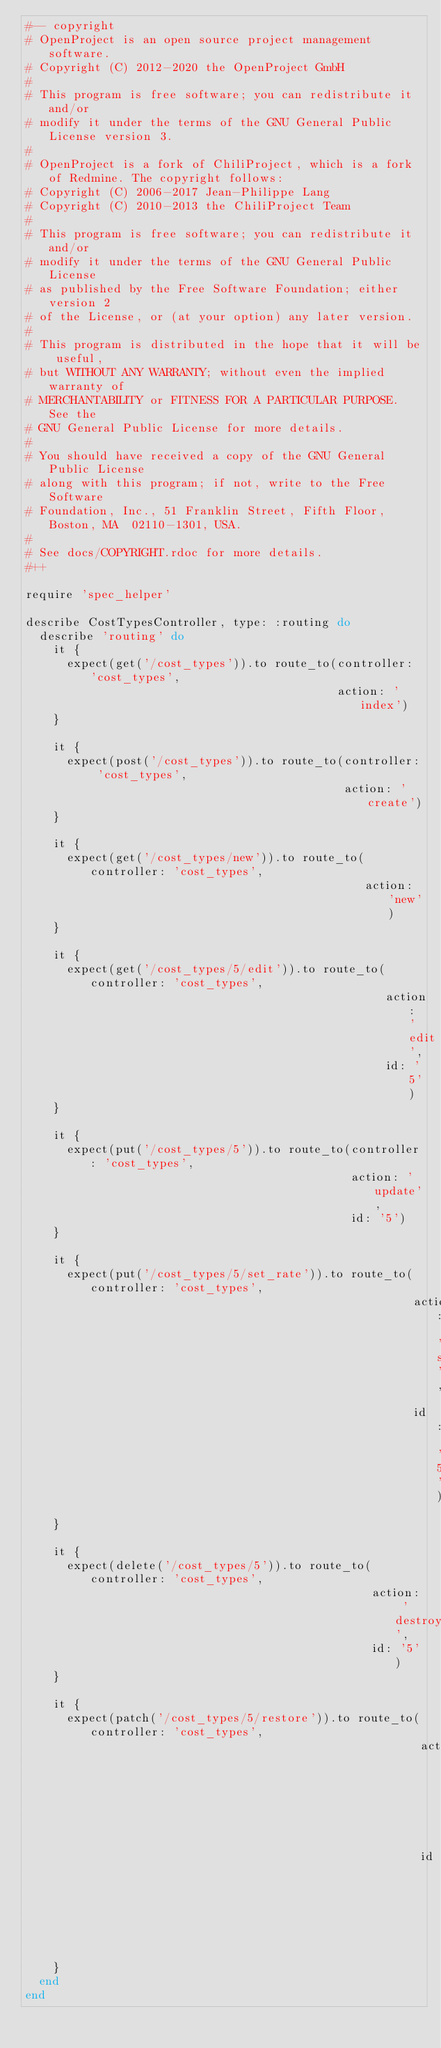<code> <loc_0><loc_0><loc_500><loc_500><_Ruby_>#-- copyright
# OpenProject is an open source project management software.
# Copyright (C) 2012-2020 the OpenProject GmbH
#
# This program is free software; you can redistribute it and/or
# modify it under the terms of the GNU General Public License version 3.
#
# OpenProject is a fork of ChiliProject, which is a fork of Redmine. The copyright follows:
# Copyright (C) 2006-2017 Jean-Philippe Lang
# Copyright (C) 2010-2013 the ChiliProject Team
#
# This program is free software; you can redistribute it and/or
# modify it under the terms of the GNU General Public License
# as published by the Free Software Foundation; either version 2
# of the License, or (at your option) any later version.
#
# This program is distributed in the hope that it will be useful,
# but WITHOUT ANY WARRANTY; without even the implied warranty of
# MERCHANTABILITY or FITNESS FOR A PARTICULAR PURPOSE.  See the
# GNU General Public License for more details.
#
# You should have received a copy of the GNU General Public License
# along with this program; if not, write to the Free Software
# Foundation, Inc., 51 Franklin Street, Fifth Floor, Boston, MA  02110-1301, USA.
#
# See docs/COPYRIGHT.rdoc for more details.
#++

require 'spec_helper'

describe CostTypesController, type: :routing do
  describe 'routing' do
    it {
      expect(get('/cost_types')).to route_to(controller: 'cost_types',
                                             action: 'index')
    }

    it {
      expect(post('/cost_types')).to route_to(controller: 'cost_types',
                                              action: 'create')
    }

    it {
      expect(get('/cost_types/new')).to route_to(controller: 'cost_types',
                                                 action: 'new')
    }

    it {
      expect(get('/cost_types/5/edit')).to route_to(controller: 'cost_types',
                                                    action: 'edit',
                                                    id: '5')
    }

    it {
      expect(put('/cost_types/5')).to route_to(controller: 'cost_types',
                                               action: 'update',
                                               id: '5')
    }

    it {
      expect(put('/cost_types/5/set_rate')).to route_to(controller: 'cost_types',
                                                        action: 'set_rate',
                                                        id: '5')
    }

    it {
      expect(delete('/cost_types/5')).to route_to(controller: 'cost_types',
                                                  action: 'destroy',
                                                  id: '5')
    }

    it {
      expect(patch('/cost_types/5/restore')).to route_to(controller: 'cost_types',
                                                         action: 'restore',
                                                         id: '5')
    }
  end
end
</code> 